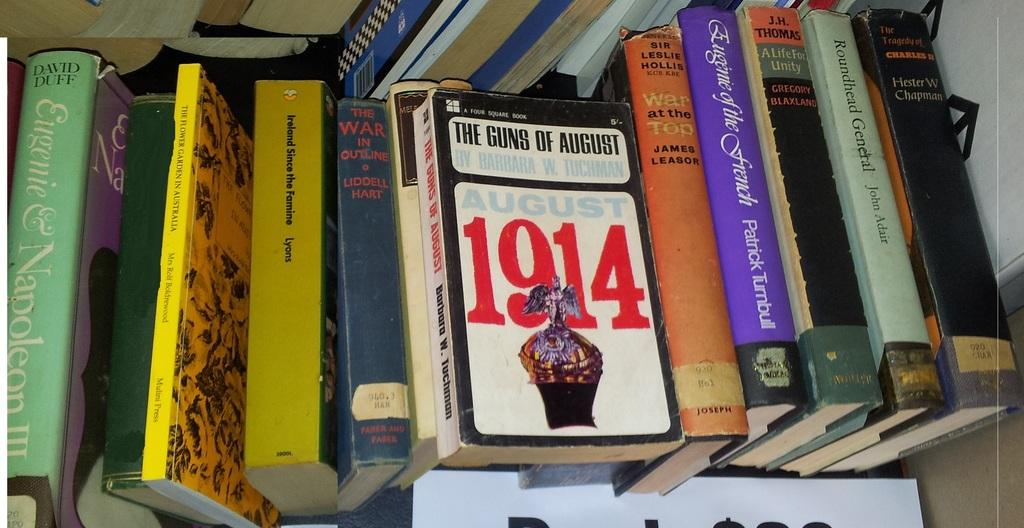<image>
Relay a brief, clear account of the picture shown. A disorganized collection of books include titles such as The Guns of August, Roundhead General and War at the Top. 